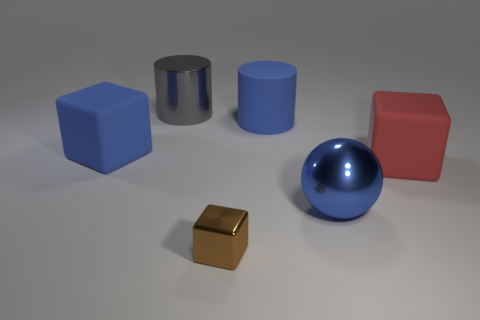Are there more large gray metallic things than brown matte things?
Your answer should be very brief. Yes. There is a matte thing that is the same color as the big rubber cylinder; what size is it?
Your answer should be compact. Large. What is the size of the thing that is in front of the large matte cylinder and on the left side of the tiny block?
Provide a succinct answer. Large. The large cube left of the matte cube on the right side of the large cylinder that is on the right side of the large gray shiny cylinder is made of what material?
Ensure brevity in your answer.  Rubber. There is a cylinder that is the same color as the shiny sphere; what is its material?
Provide a short and direct response. Rubber. There is a block in front of the red rubber thing; does it have the same color as the metal thing that is behind the large red cube?
Your response must be concise. No. There is a large shiny thing that is to the right of the metal thing behind the large thing to the left of the big shiny cylinder; what shape is it?
Your answer should be very brief. Sphere. There is a metal object that is both behind the brown cube and on the left side of the big blue metal ball; what shape is it?
Your answer should be very brief. Cylinder. What number of rubber blocks are on the left side of the big blue thing that is in front of the big rubber block that is on the right side of the blue rubber block?
Ensure brevity in your answer.  1. There is another rubber object that is the same shape as the big red object; what is its size?
Offer a terse response. Large. 